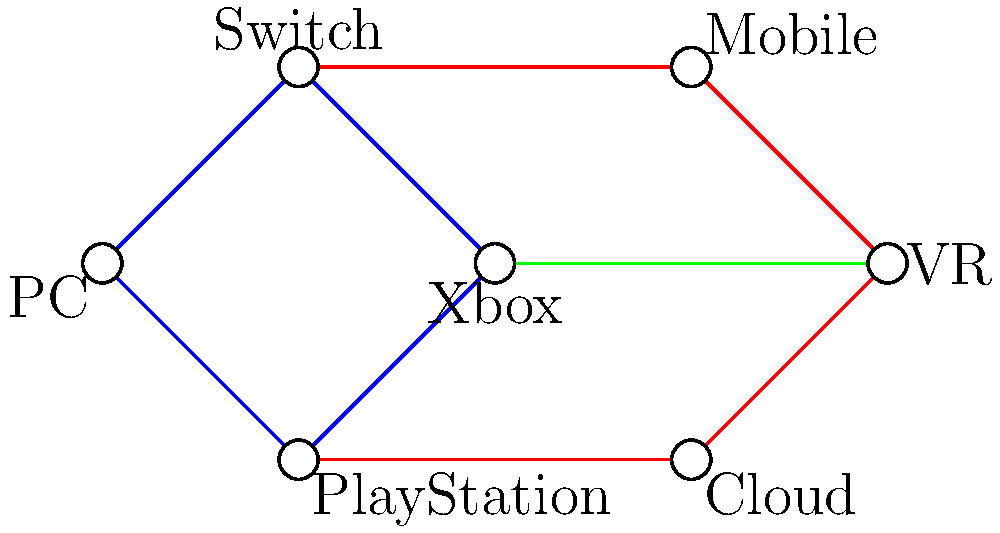In a new cross-platform multiplayer game, different gaming platforms are connected as shown in the graph. Each vertex represents a platform, and edges represent direct connectivity between platforms. If the game servers go down for the Switch, what is the minimum number of additional platform connections needed to ensure all remaining platforms can still communicate with each other? To solve this problem, we need to follow these steps:

1. Understand the current connectivity:
   - PC, Switch, Xbox, and PlayStation form a cycle (blue edges)
   - Switch, Mobile, VR, Cloud, and PlayStation form another cycle (red edges)
   - Xbox and VR have a direct connection (green edge)

2. Remove the Switch node and its connections:
   - This breaks both cycles and disconnects Mobile from the rest of the network

3. Analyze the remaining components:
   - Component 1: PC, Xbox, PlayStation, VR, Cloud
   - Component 2: Mobile (isolated)

4. Determine the minimum number of connections needed:
   - We need to connect Mobile to any node in Component 1
   - One connection is sufficient to make the graph connected again

5. Verify the solution:
   - Adding one edge from Mobile to any node in Component 1 (e.g., Mobile to PC) will ensure all platforms can communicate

Therefore, the minimum number of additional platform connections needed is 1.
Answer: 1 